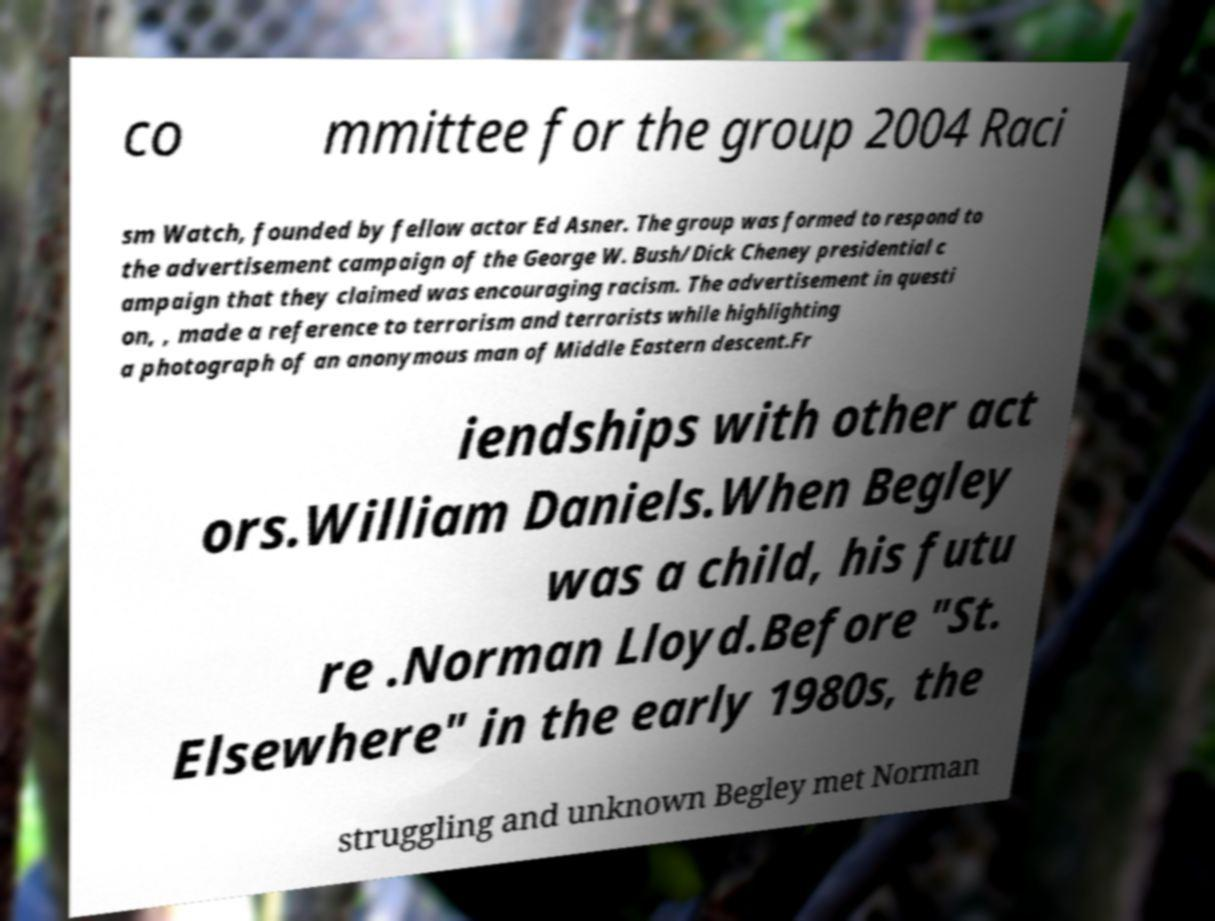Can you accurately transcribe the text from the provided image for me? co mmittee for the group 2004 Raci sm Watch, founded by fellow actor Ed Asner. The group was formed to respond to the advertisement campaign of the George W. Bush/Dick Cheney presidential c ampaign that they claimed was encouraging racism. The advertisement in questi on, , made a reference to terrorism and terrorists while highlighting a photograph of an anonymous man of Middle Eastern descent.Fr iendships with other act ors.William Daniels.When Begley was a child, his futu re .Norman Lloyd.Before "St. Elsewhere" in the early 1980s, the struggling and unknown Begley met Norman 